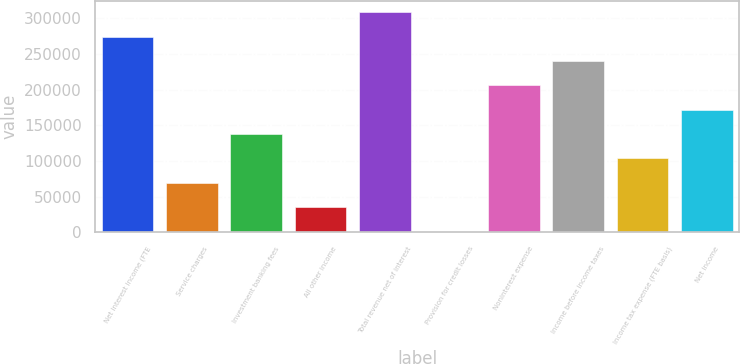<chart> <loc_0><loc_0><loc_500><loc_500><bar_chart><fcel>Net interest income (FTE<fcel>Service charges<fcel>Investment banking fees<fcel>All other income<fcel>Total revenue net of interest<fcel>Provision for credit losses<fcel>Noninterest expense<fcel>Income before income taxes<fcel>Income tax expense (FTE basis)<fcel>Net income<nl><fcel>274433<fcel>69414.4<fcel>137754<fcel>35244.7<fcel>308602<fcel>1075<fcel>206093<fcel>240263<fcel>103584<fcel>171924<nl></chart> 